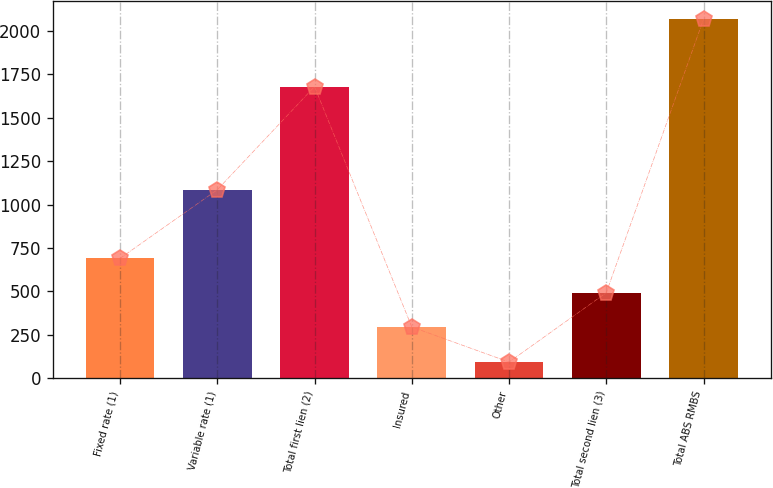<chart> <loc_0><loc_0><loc_500><loc_500><bar_chart><fcel>Fixed rate (1)<fcel>Variable rate (1)<fcel>Total first lien (2)<fcel>Insured<fcel>Other<fcel>Total second lien (3)<fcel>Total ABS RMBS<nl><fcel>689.8<fcel>1085<fcel>1679<fcel>295<fcel>93<fcel>492.4<fcel>2067<nl></chart> 